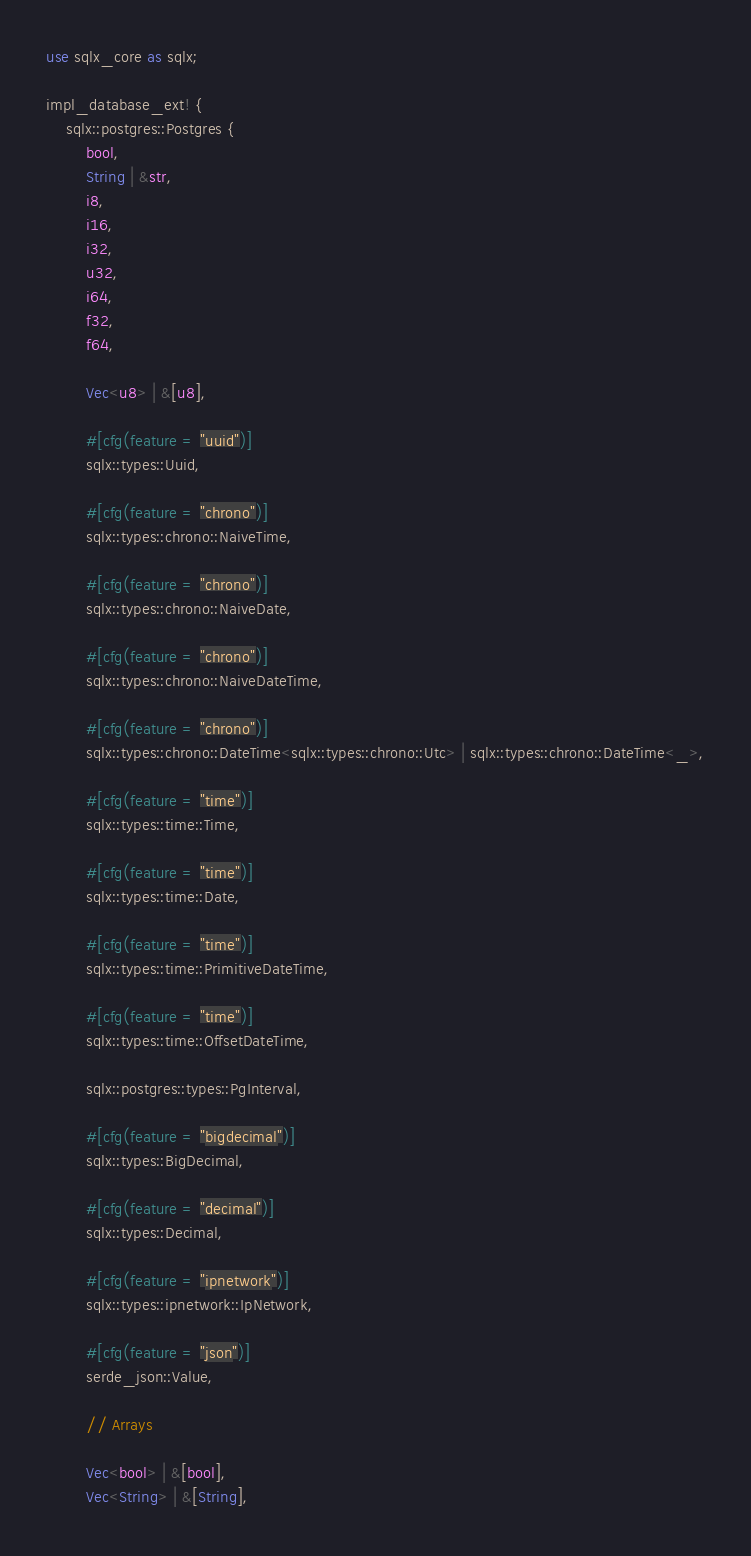Convert code to text. <code><loc_0><loc_0><loc_500><loc_500><_Rust_>use sqlx_core as sqlx;

impl_database_ext! {
    sqlx::postgres::Postgres {
        bool,
        String | &str,
        i8,
        i16,
        i32,
        u32,
        i64,
        f32,
        f64,

        Vec<u8> | &[u8],

        #[cfg(feature = "uuid")]
        sqlx::types::Uuid,

        #[cfg(feature = "chrono")]
        sqlx::types::chrono::NaiveTime,

        #[cfg(feature = "chrono")]
        sqlx::types::chrono::NaiveDate,

        #[cfg(feature = "chrono")]
        sqlx::types::chrono::NaiveDateTime,

        #[cfg(feature = "chrono")]
        sqlx::types::chrono::DateTime<sqlx::types::chrono::Utc> | sqlx::types::chrono::DateTime<_>,

        #[cfg(feature = "time")]
        sqlx::types::time::Time,

        #[cfg(feature = "time")]
        sqlx::types::time::Date,

        #[cfg(feature = "time")]
        sqlx::types::time::PrimitiveDateTime,

        #[cfg(feature = "time")]
        sqlx::types::time::OffsetDateTime,

        sqlx::postgres::types::PgInterval,

        #[cfg(feature = "bigdecimal")]
        sqlx::types::BigDecimal,

        #[cfg(feature = "decimal")]
        sqlx::types::Decimal,

        #[cfg(feature = "ipnetwork")]
        sqlx::types::ipnetwork::IpNetwork,

        #[cfg(feature = "json")]
        serde_json::Value,

        // Arrays

        Vec<bool> | &[bool],
        Vec<String> | &[String],</code> 